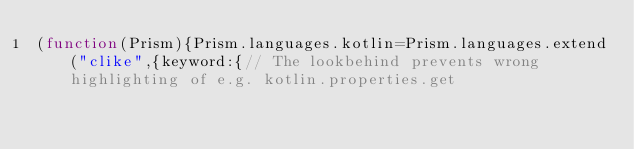Convert code to text. <code><loc_0><loc_0><loc_500><loc_500><_JavaScript_>(function(Prism){Prism.languages.kotlin=Prism.languages.extend("clike",{keyword:{// The lookbehind prevents wrong highlighting of e.g. kotlin.properties.get</code> 